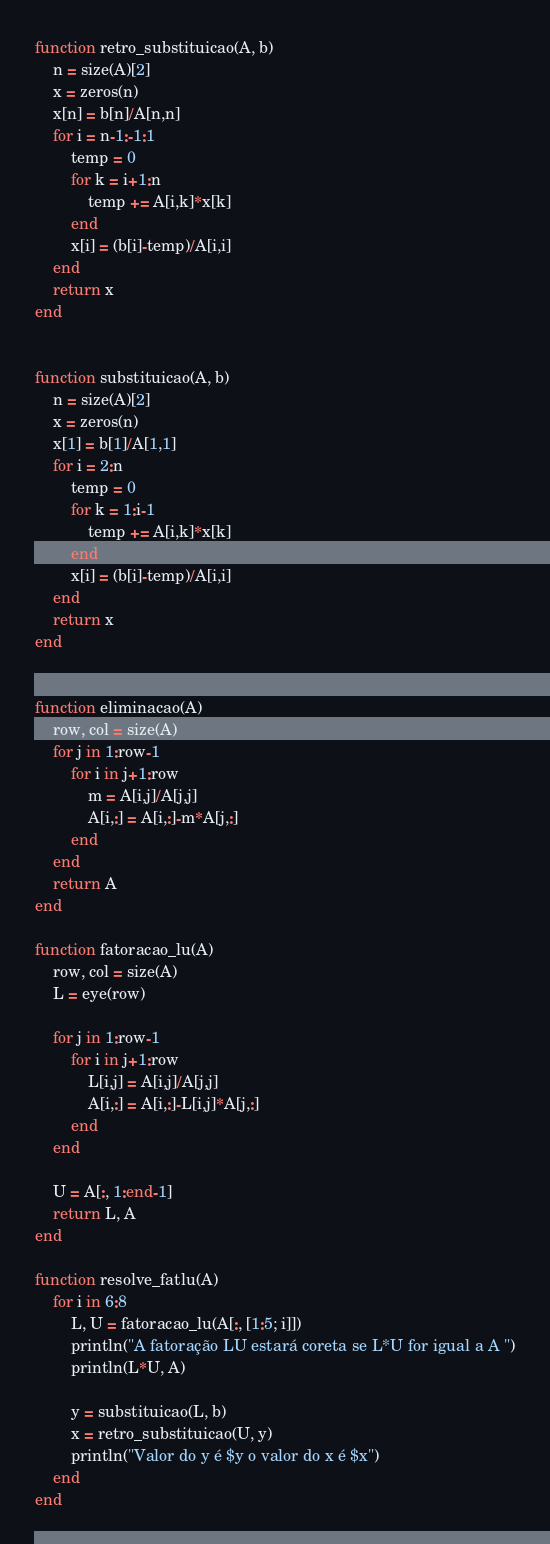<code> <loc_0><loc_0><loc_500><loc_500><_Julia_>function retro_substituicao(A, b)
    n = size(A)[2]
    x = zeros(n)
    x[n] = b[n]/A[n,n]
    for i = n-1:-1:1
        temp = 0
        for k = i+1:n
            temp += A[i,k]*x[k]
        end
        x[i] = (b[i]-temp)/A[i,i]
    end
    return x
end


function substituicao(A, b)
    n = size(A)[2]
    x = zeros(n)
    x[1] = b[1]/A[1,1]
    for i = 2:n
        temp = 0
        for k = 1:i-1
            temp += A[i,k]*x[k]
        end
        x[i] = (b[i]-temp)/A[i,i]
    end
    return x
end


function eliminacao(A)
    row, col = size(A)
    for j in 1:row-1
        for i in j+1:row
            m = A[i,j]/A[j,j]
            A[i,:] = A[i,:]-m*A[j,:]
        end
    end
    return A
end

function fatoracao_lu(A)
    row, col = size(A)
    L = eye(row)

    for j in 1:row-1
        for i in j+1:row
            L[i,j] = A[i,j]/A[j,j]
            A[i,:] = A[i,:]-L[i,j]*A[j,:]
        end
    end

    U = A[:, 1:end-1]
    return L, A
end

function resolve_fatlu(A)
    for i in 6:8
        L, U = fatoracao_lu(A[:, [1:5; i]])
        println("A fatoração LU estará coreta se L*U for igual a A ")
        println(L*U, A)

        y = substituicao(L, b)
        x = retro_substituicao(U, y)
        println("Valor do y é $y o valor do x é $x")
    end
end
</code> 